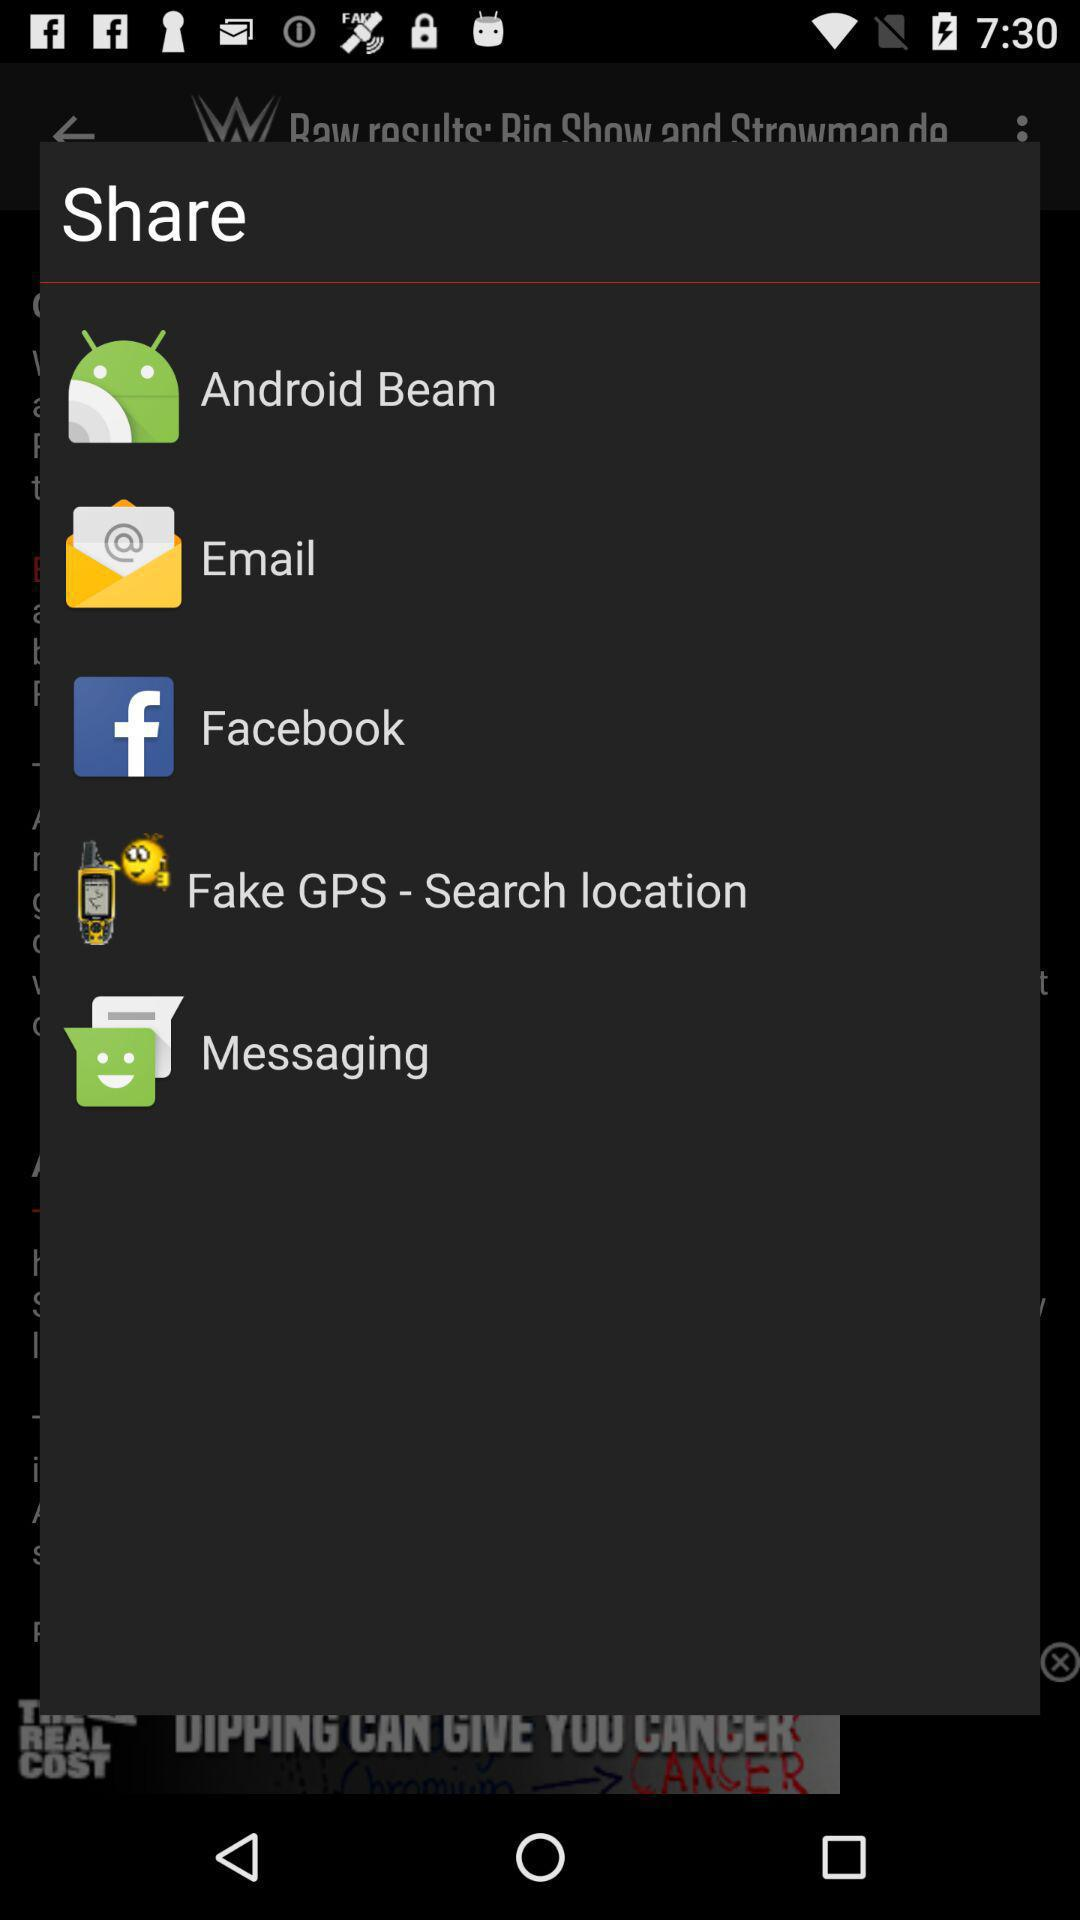How many items are in the share menu?
Answer the question using a single word or phrase. 5 